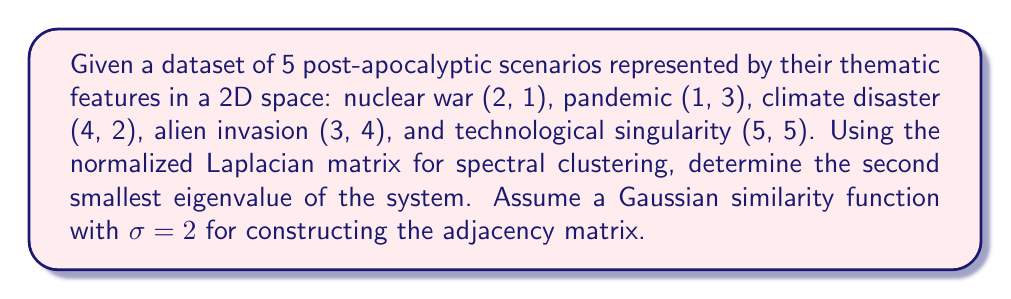Solve this math problem. 1. Construct the adjacency matrix A using the Gaussian similarity function:
   $A_{ij} = e^{-\frac{||x_i - x_j||^2}{2\sigma^2}}$ where $\sigma = 2$

2. Calculate the degree matrix D:
   $D_{ii} = \sum_{j=1}^n A_{ij}$

3. Compute the normalized Laplacian matrix L:
   $L = I - D^{-1/2}AD^{-1/2}$

4. Calculate the eigenvalues of L

5. Identify the second smallest eigenvalue

Step 1: Construct the adjacency matrix A
$$A = \begin{bmatrix}
1 & 0.7788 & 0.8825 & 0.6977 & 0.4724 \\
0.7788 & 1 & 0.6065 & 0.8825 & 0.6065 \\
0.8825 & 0.6065 & 1 & 0.7788 & 0.6977 \\
0.6977 & 0.8825 & 0.7788 & 1 & 0.8825 \\
0.4724 & 0.6065 & 0.6977 & 0.8825 & 1
\end{bmatrix}$$

Step 2: Calculate the degree matrix D
$$D = \begin{bmatrix}
3.8314 & 0 & 0 & 0 & 0 \\
0 & 3.8743 & 0 & 0 & 0 \\
0 & 0 & 3.9655 & 0 & 0 \\
0 & 0 & 0 & 4.2415 & 0 \\
0 & 0 & 0 & 0 & 3.6591
\end{bmatrix}$$

Step 3: Compute the normalized Laplacian matrix L
$$L = I - D^{-1/2}AD^{-1/2}$$

Step 4: Calculate the eigenvalues of L
Using a computer algebra system, we find the eigenvalues:
$\lambda_1 = 0$
$\lambda_2 \approx 0.0891$
$\lambda_3 \approx 0.2104$
$\lambda_4 \approx 0.3687$
$\lambda_5 \approx 0.4318$

Step 5: Identify the second smallest eigenvalue
The second smallest eigenvalue is $\lambda_2 \approx 0.0891$
Answer: $0.0891$ 